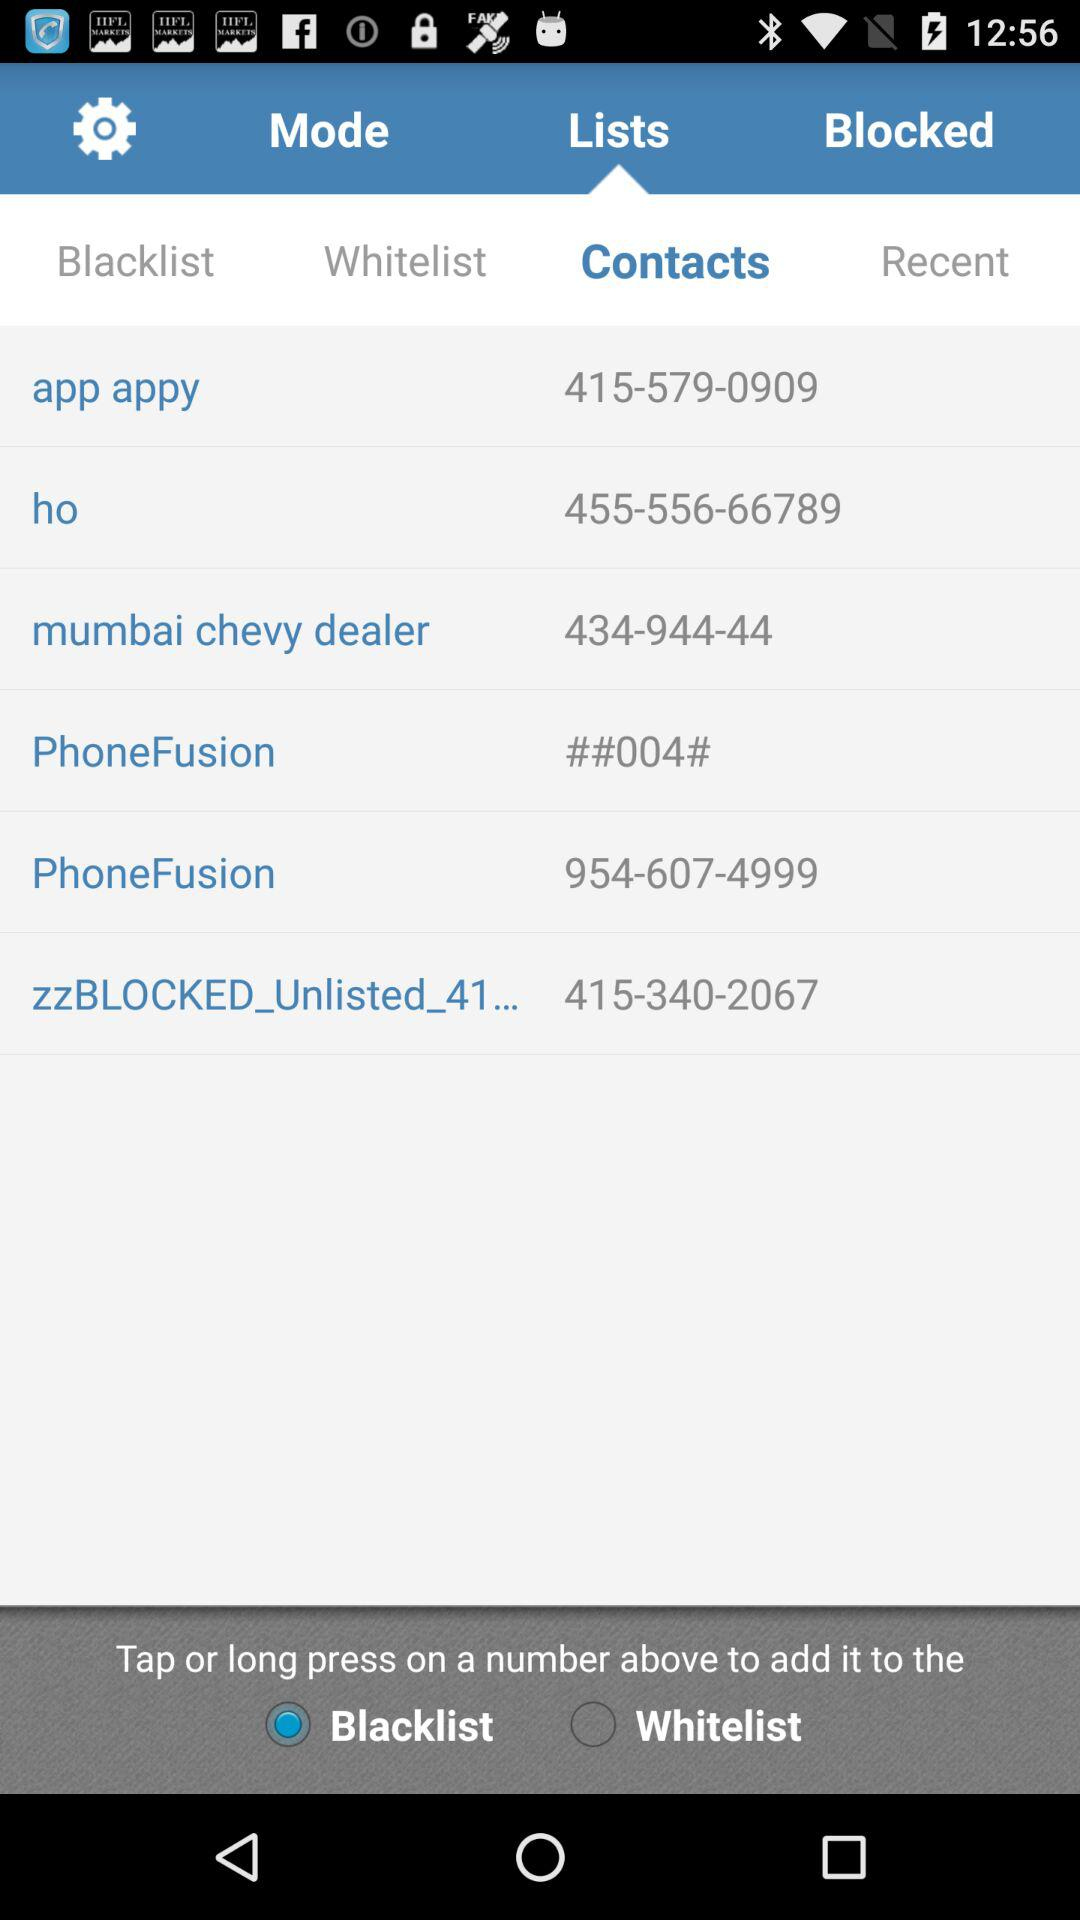Which tab am I on? You are on "Lists" and "Contacts" tabs. 